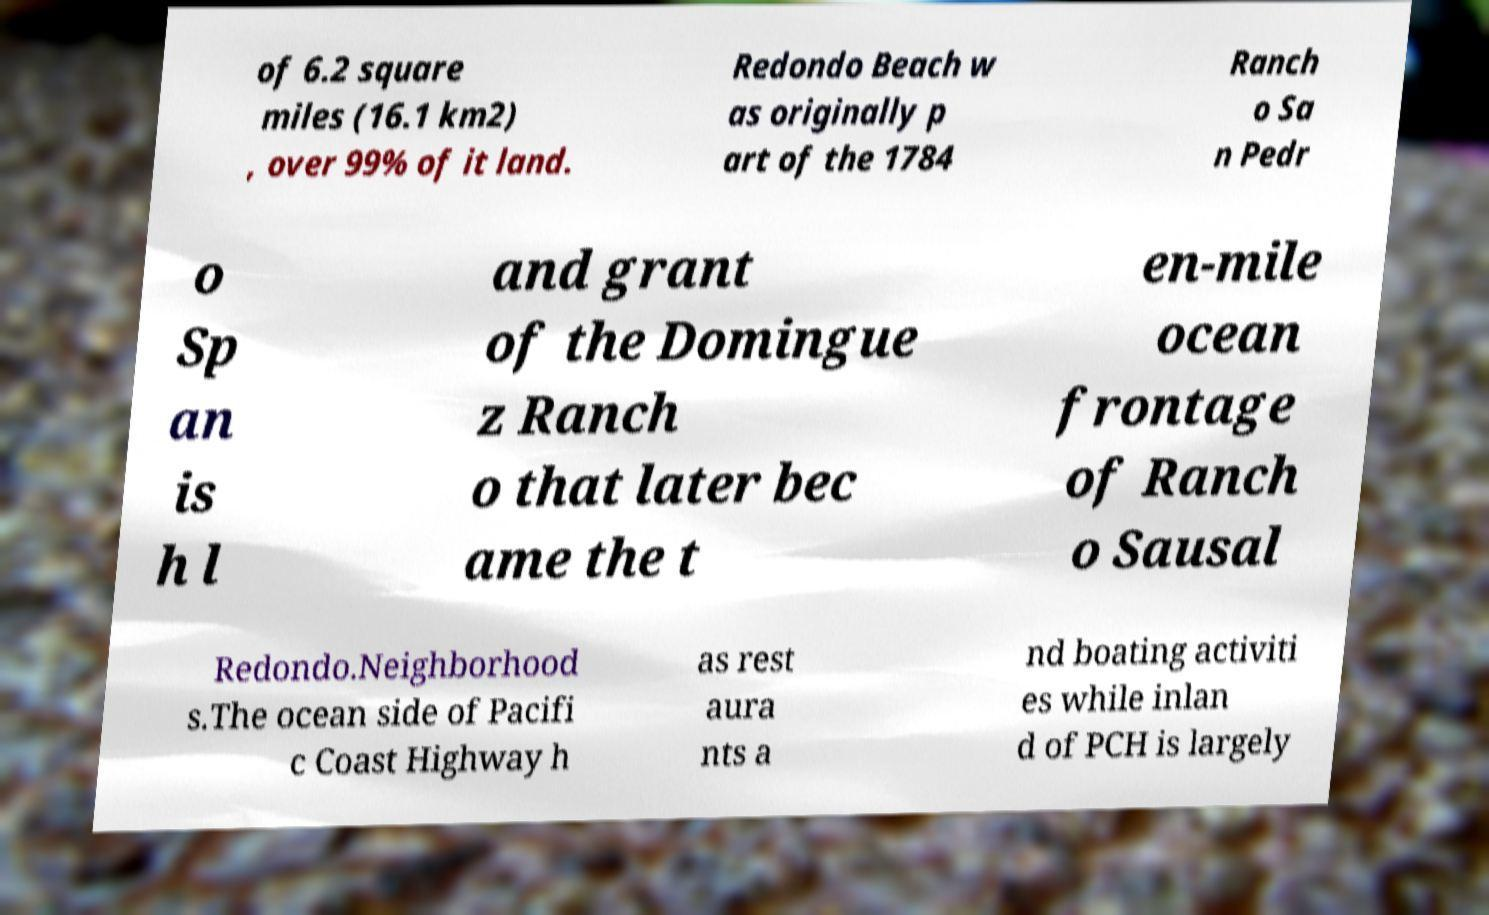Could you assist in decoding the text presented in this image and type it out clearly? of 6.2 square miles (16.1 km2) , over 99% of it land. Redondo Beach w as originally p art of the 1784 Ranch o Sa n Pedr o Sp an is h l and grant of the Domingue z Ranch o that later bec ame the t en-mile ocean frontage of Ranch o Sausal Redondo.Neighborhood s.The ocean side of Pacifi c Coast Highway h as rest aura nts a nd boating activiti es while inlan d of PCH is largely 